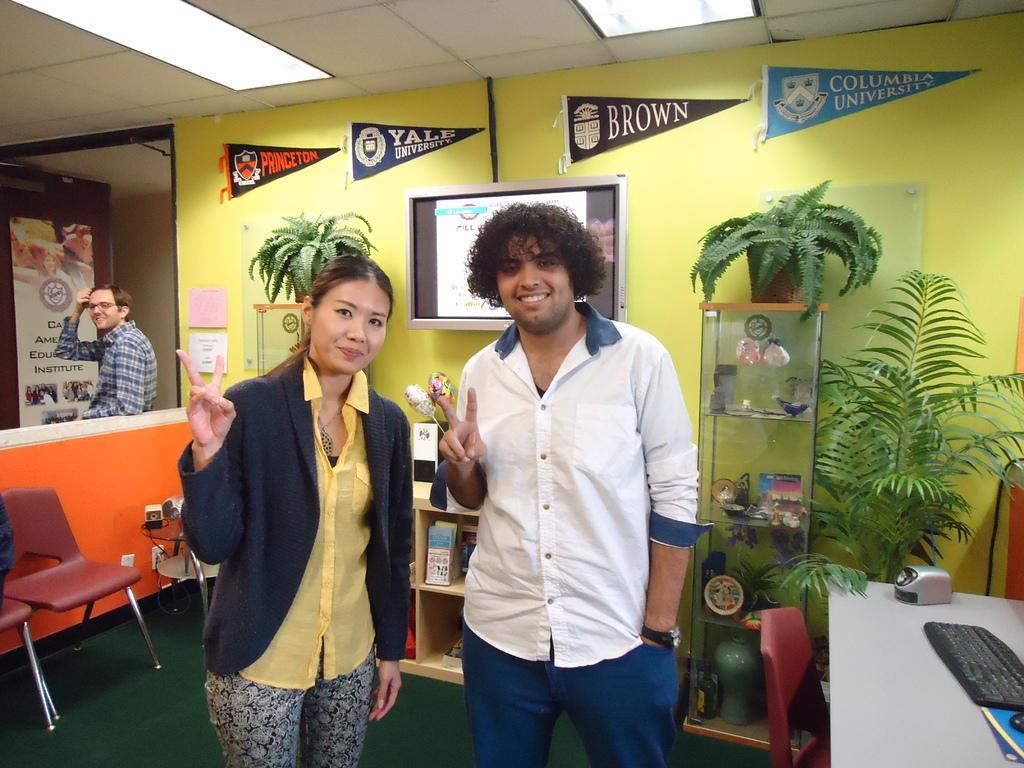How would you summarize this image in a sentence or two? It seems to be the image is inside the room. In the image there are three people two men's and one woman who are standing on right there is a table, on table we can see a keyboard,speaker,mouse and we can also a chair,plants. On left side there is a door which is opened. In background we can see television on top there is a roof with few lights and bottom there is a land which is in green color. 